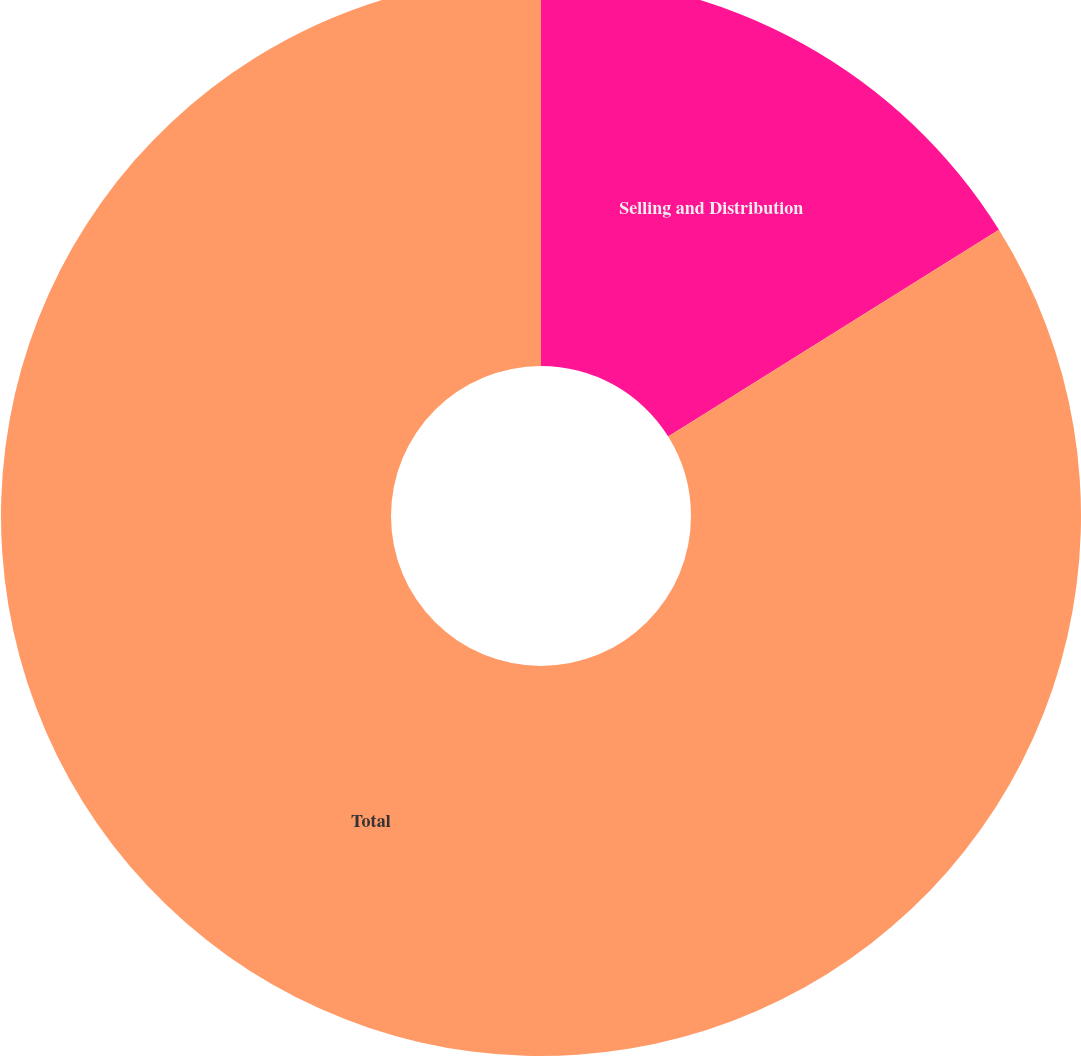Convert chart. <chart><loc_0><loc_0><loc_500><loc_500><pie_chart><fcel>Selling and Distribution<fcel>Total<nl><fcel>16.11%<fcel>83.89%<nl></chart> 